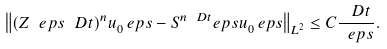<formula> <loc_0><loc_0><loc_500><loc_500>\left \| ( Z _ { \ } e p s ^ { \ } D t ) ^ { n } u _ { 0 } ^ { \ } e p s - S ^ { n \ D t } _ { \ } e p s u _ { 0 } ^ { \ } e p s \right \| _ { L ^ { 2 } } \leq C \frac { \ D t } { \ e p s } .</formula> 